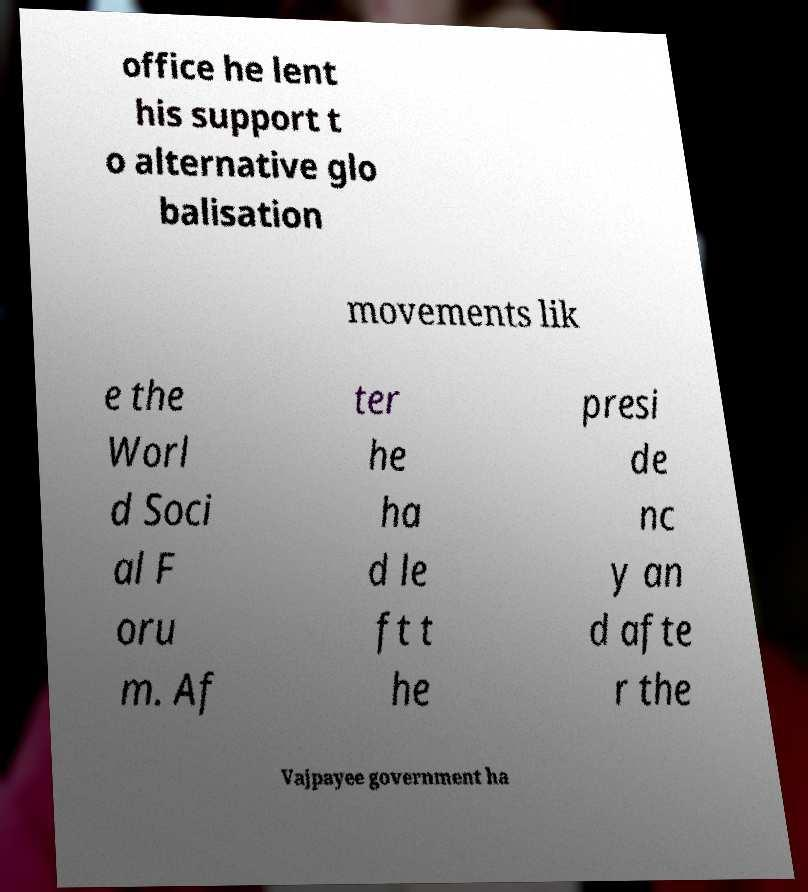Please identify and transcribe the text found in this image. office he lent his support t o alternative glo balisation movements lik e the Worl d Soci al F oru m. Af ter he ha d le ft t he presi de nc y an d afte r the Vajpayee government ha 